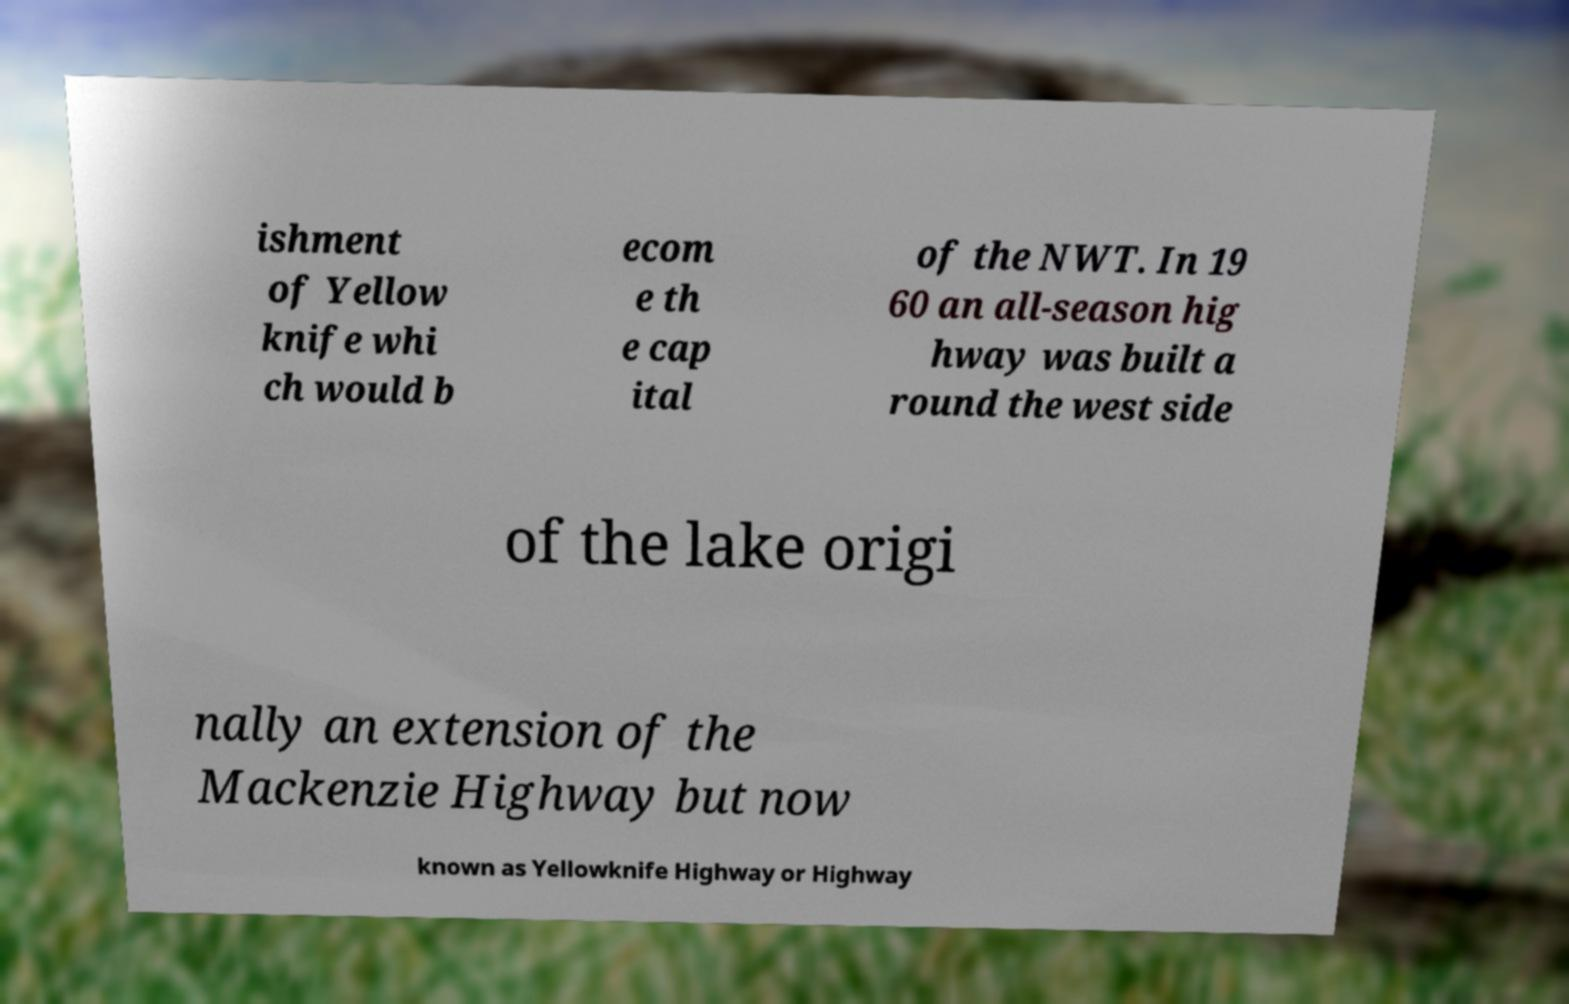I need the written content from this picture converted into text. Can you do that? ishment of Yellow knife whi ch would b ecom e th e cap ital of the NWT. In 19 60 an all-season hig hway was built a round the west side of the lake origi nally an extension of the Mackenzie Highway but now known as Yellowknife Highway or Highway 